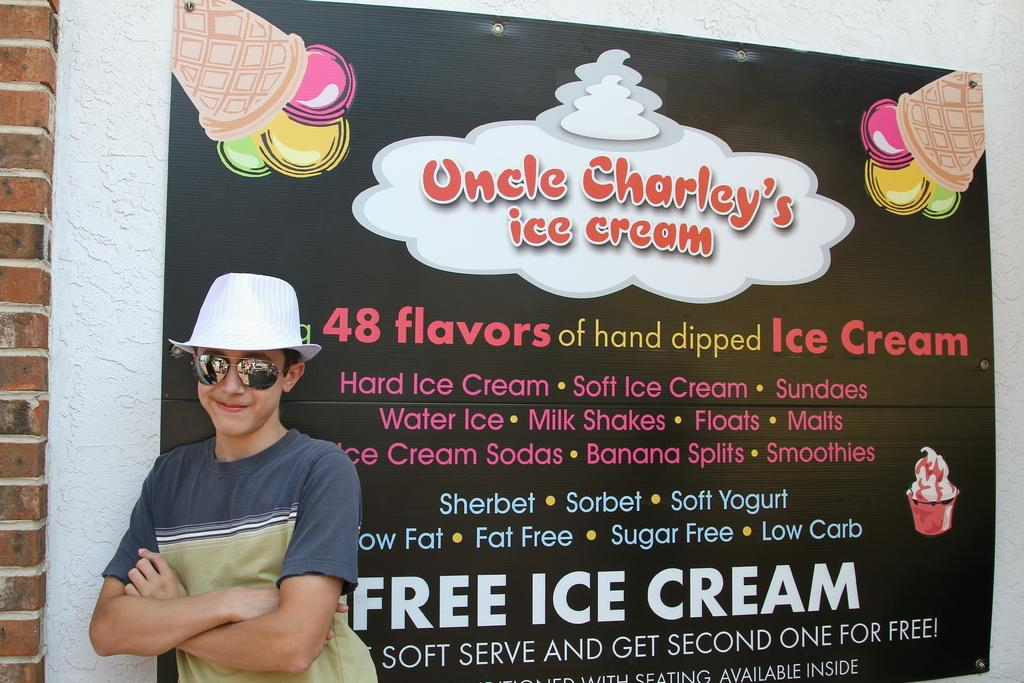Who is present in the image? There is a man in the image. What accessories is the man wearing? The man is wearing glasses and a hat. Where is the man positioned in relation to the pillar? The man is standing near a pillar. What can be seen in the background of the image? There is a banner in the background of the image. What is written on the banner? There is text on the banner. What type of skin condition can be seen on the man's face in the image? There is no indication of a skin condition on the man's face in the image. What season is it in the image, considering the man's attire? The man's attire does not provide any indication of the season, as he is wearing a hat and glasses, which are not season-specific. 